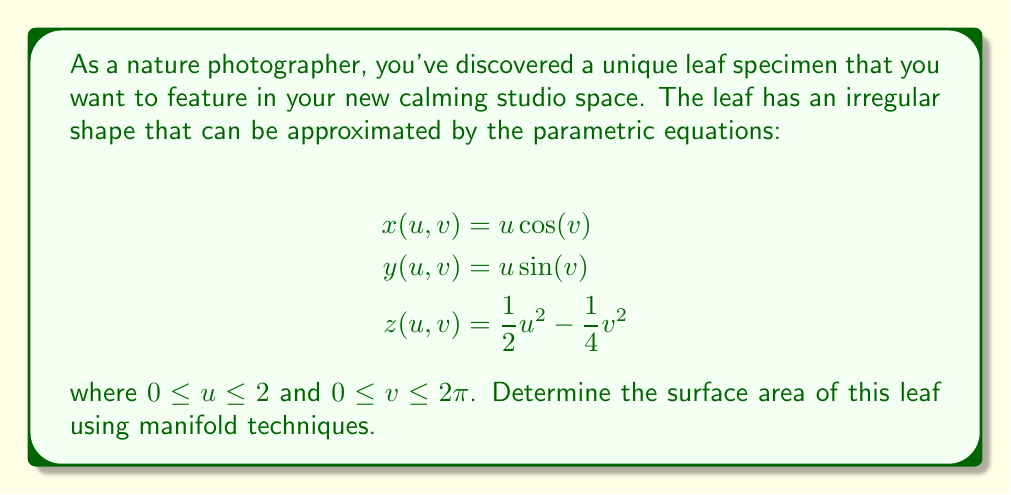Give your solution to this math problem. To find the surface area of the leaf using manifold techniques, we need to follow these steps:

1) First, we need to calculate the partial derivatives of x, y, and z with respect to u and v:

   $$\frac{\partial x}{\partial u} = \cos(v), \frac{\partial x}{\partial v} = -u\sin(v)$$
   $$\frac{\partial y}{\partial u} = \sin(v), \frac{\partial y}{\partial v} = u\cos(v)$$
   $$\frac{\partial z}{\partial u} = u, \frac{\partial z}{\partial v} = -\frac{1}{2}v$$

2) Next, we need to compute the cross product of the partial derivatives:

   $$\left|\frac{\partial \mathbf{r}}{\partial u} \times \frac{\partial \mathbf{r}}{\partial v}\right| = \left|\begin{vmatrix}
   \mathbf{i} & \mathbf{j} & \mathbf{k} \\
   \cos(v) & \sin(v) & u \\
   -u\sin(v) & u\cos(v) & -\frac{1}{2}v
   \end{vmatrix}\right|$$

3) Evaluating this determinant:

   $$\left|\frac{\partial \mathbf{r}}{\partial u} \times \frac{\partial \mathbf{r}}{\partial v}\right| = \sqrt{u^2\cos^2(v) + u^2\sin^2(v) + (u^2 + \frac{1}{4}v^2)^2}$$

4) Simplify:

   $$\left|\frac{\partial \mathbf{r}}{\partial u} \times \frac{\partial \mathbf{r}}{\partial v}\right| = \sqrt{u^2 + (u^2 + \frac{1}{4}v^2)^2}$$

5) The surface area is given by the double integral:

   $$A = \int_0^{2\pi} \int_0^2 \sqrt{u^2 + (u^2 + \frac{1}{4}v^2)^2} \, du \, dv$$

6) This integral cannot be evaluated analytically, so we need to use numerical methods to approximate the result.

7) Using a numerical integration method (such as Simpson's rule or a computer algebra system), we can approximate the integral to get the surface area.
Answer: The surface area of the leaf is approximately 26.8 square units (rounded to one decimal place). This result is obtained through numerical integration of the surface area integral. 